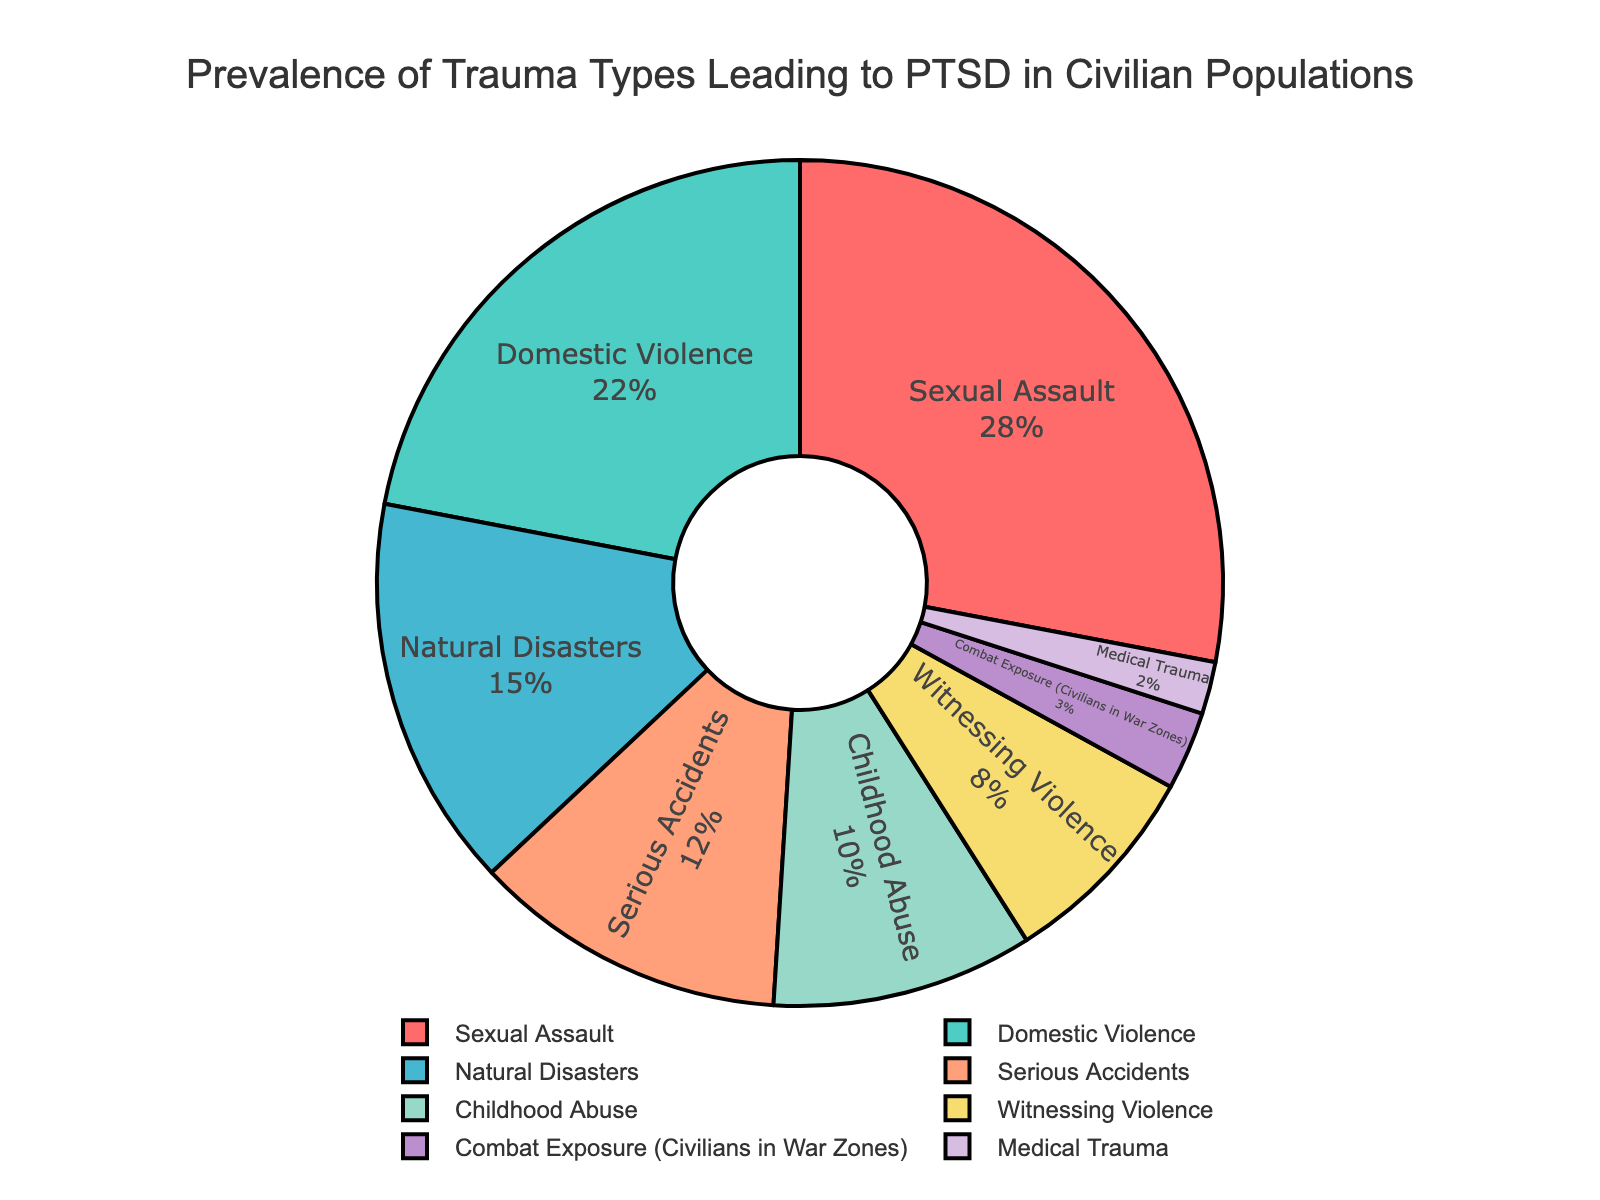What's the most common trauma type leading to PTSD in civilian populations? The pie chart shows the percentage of different trauma types leading to PTSD. The segment representing the largest percentage indicates the most common trauma type. From the chart, "Sexual Assault" has the largest portion.
Answer: Sexual Assault Which trauma type has the smallest prevalence for leading to PTSD in civilian populations? In the pie chart, the smallest segment represents the least common trauma type. "Medical Trauma" has the smallest segment, indicating it is the least prevalent.
Answer: Medical Trauma What is the combined percentage of Sexual Assault and Domestic Violence as causes of PTSD? By adding the percentages of Sexual Assault (28%) and Domestic Violence (22%), we get the combined percentage that accounts for these two trauma types. 28% + 22% = 50%.
Answer: 50% How much more prevalent is Sexual Assault compared to Combat Exposure in civilian war zones? To find the difference between the prevalence of Sexual Assault (28%) and Combat Exposure in civilian war zones (3%), subtract the smaller percentage from the larger one. 28% - 3% = 25%.
Answer: 25% Arrange the trauma types leading to PTSD in order from most prevalent to least prevalent. By examining the pie chart’s segments from largest to smallest, we can determine the order:
1. Sexual Assault (28%)
2. Domestic Violence (22%)
3. Natural Disasters (15%)
4. Serious Accidents (12%)
5. Childhood Abuse (10%)
6. Witnessing Violence (8%)
7. Combat Exposure (3%)
8. Medical Trauma (2%)
Answer: Sexual Assault, Domestic Violence, Natural Disasters, Serious Accidents, Childhood Abuse, Witnessing Violence, Combat Exposure, Medical Trauma Are Natural Disasters or Serious Accidents a more prevalent cause of PTSD, and by how much? Compare the percentage values for Natural Disasters (15%) and Serious Accidents (12%). The difference between the two percentages is 15% - 12% = 3%.
Answer: Natural Disasters, by 3% What percentage of PTSD causes are due to traumas other than Sexual Assault, Domestic Violence, and Natural Disasters? To find this percentage, first, sum up the percentages of Sexual Assault (28%), Domestic Violence (22%), and Natural Disasters (15%). Then subtract this total from 100% to get the remainder percentage. 100% - (28% + 22% + 15%) = 35%.
Answer: 35% Is Childhood Abuse more or less prevalent than Witnessing Violence as a cause of PTSD, and by what percentage? Compare the percentages of Childhood Abuse (10%) and Witnessing Violence (8%). The difference between the two percentages is 10% - 8% = 2%.
Answer: Childhood Abuse, by 2% What is the total percentage for Serious Accidents, Childhood Abuse, and Witnessing Violence combined? Add the percentages of Serious Accidents (12%), Childhood Abuse (10%), and Witnessing Violence (8%). 12% + 10% + 8% = 30%.
Answer: 30% Which trauma types are represented with the colors red and green? The pie chart's segments use different colors. By identifying the colors associated with particular trauma types: "Sexual Assault" is red and "Domestic Violence" is green.
Answer: Sexual Assault (red), Domestic Violence (green) 